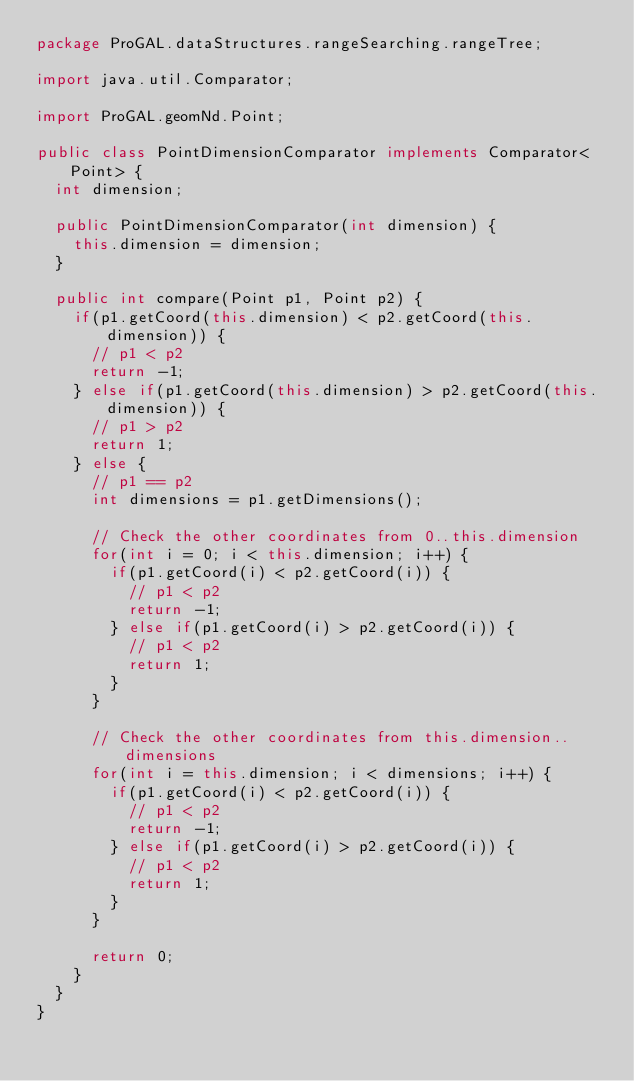Convert code to text. <code><loc_0><loc_0><loc_500><loc_500><_Java_>package ProGAL.dataStructures.rangeSearching.rangeTree;

import java.util.Comparator;

import ProGAL.geomNd.Point;

public class PointDimensionComparator implements Comparator<Point> {
	int dimension;
	
	public PointDimensionComparator(int dimension) {
		this.dimension = dimension;
	}

	public int compare(Point p1, Point p2) {
		if(p1.getCoord(this.dimension) < p2.getCoord(this.dimension)) {
			// p1 < p2
			return -1;
		} else if(p1.getCoord(this.dimension) > p2.getCoord(this.dimension)) {
			// p1 > p2
			return 1;
		} else {
			// p1 == p2
			int dimensions = p1.getDimensions();
			
			// Check the other coordinates from 0..this.dimension
			for(int i = 0; i < this.dimension; i++) {
				if(p1.getCoord(i) < p2.getCoord(i)) {
					// p1 < p2
					return -1;
				} else if(p1.getCoord(i) > p2.getCoord(i)) {
					// p1 < p2
					return 1;
				}
			}
			
			// Check the other coordinates from this.dimension..dimensions
			for(int i = this.dimension; i < dimensions; i++) {
				if(p1.getCoord(i) < p2.getCoord(i)) {
					// p1 < p2
					return -1;
				} else if(p1.getCoord(i) > p2.getCoord(i)) {
					// p1 < p2
					return 1;
				}
			}
			
			return 0;
		}
	}
}
</code> 